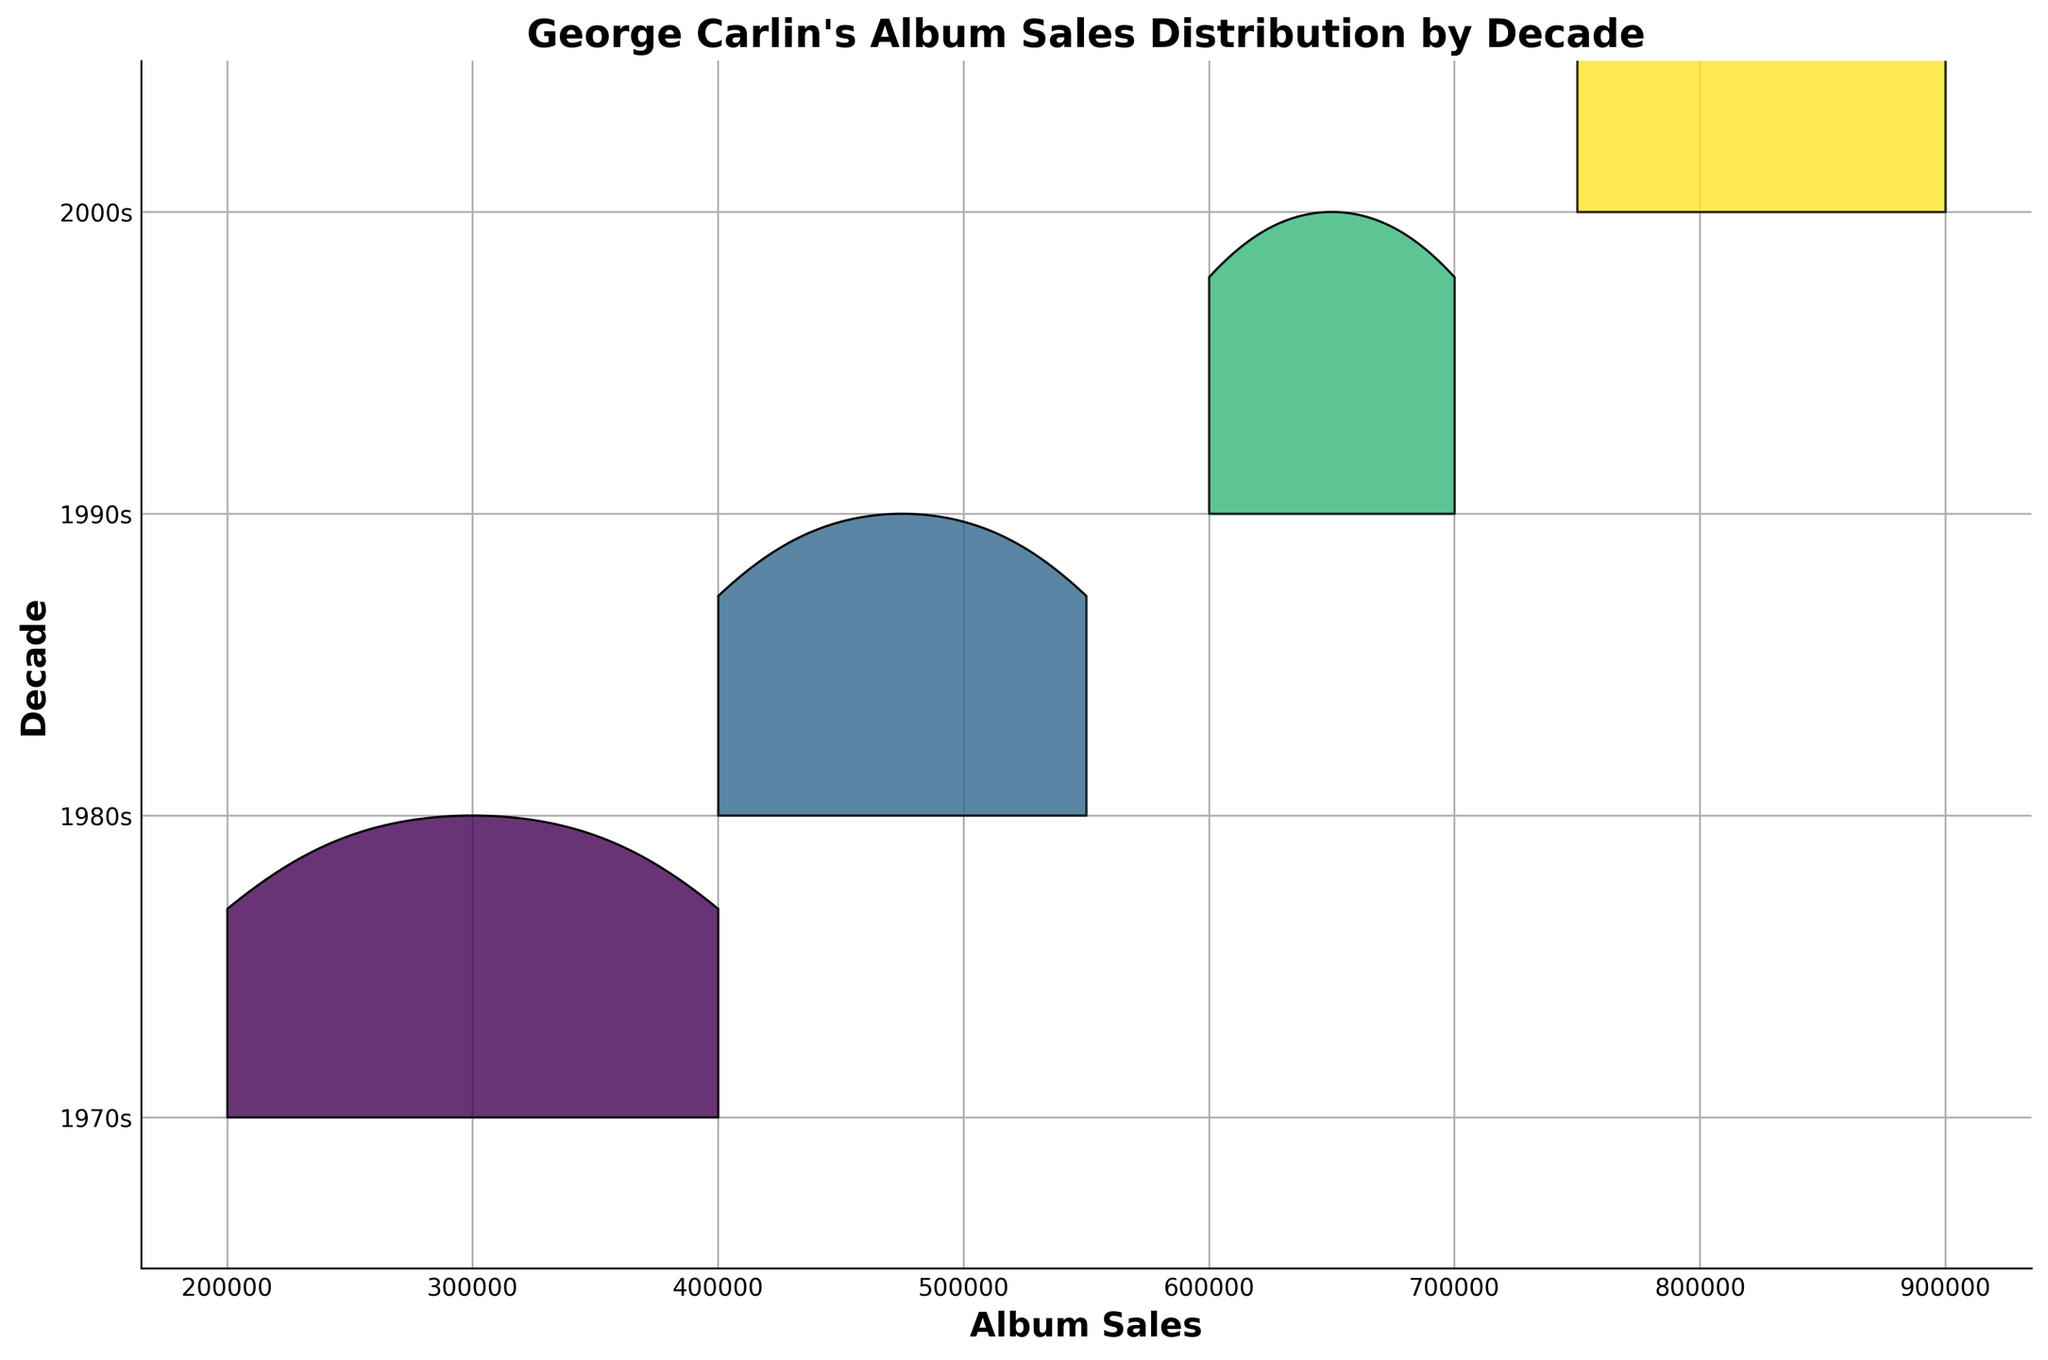What is the title of the figure? The title of the figure is typically located at the top and provides a brief description of what the plot represents. In this case, it should be centered at the top of the Ridgeline plot.
Answer: George Carlin's Album Sales Distribution by Decade What does the x-axis represent? The x-axis label is usually found below the x-axis line and states what the axis measures. In this plot, the label reads "Album Sales," which means it measures the number of albums sold.
Answer: Album Sales How many decades are displayed in the plot? The y-axis provides a list of the decades represented in the plot, from the 1970s to the 2000s. By counting the distinct labels on the y-axis, we can determine the number of decades.
Answer: 4 Which decade shows the highest peak in album sales? The peak of the highest distribution curve on the plot indicates the decade with the highest album sales. The heights of the curves show where the album sales were concentrated.
Answer: 2000s What decade had the least album sales variability? The variability in sales is visually represented by the width of the distribution. A narrower curve means less variability in sales. By examining the widths, the decade with the narrowest curve is identified.
Answer: 1970s Which decade had the highest median sales value? To find the median sales value, find the peak center of each distribution curve. The 2000s have the highest peak center, indicating the highest median sales value relative to the other decades.
Answer: 2000s What album had the highest sales in the 1980s? The peak value within the distribution for the 1980s decade can be cross-referenced with the data, wherein "What Am I Doing in New Jersey?" has the highest sale.
Answer: What Am I Doing in New Jersey? Which decade has more variability in album sales, the 1980s or 1990s? Compare the widths of the KDE curves for the 1980s and 1990s. The decade with the wider curve has more sale variability.
Answer: 1990s Are there any decades with overlapping sales distributions? We look at the KDE distribution curves to see if any curves overlap significantly, which indicates overlapping sales distributions.
Answer: Yes What is the approximate album sales range for the 2000s decade? The range can be determined by the span of the x-axis values covered by the KDE curve for the 2000s. This span depicts the minimum and maximum album sales for that decade.
Answer: 750,000 - 900,000 